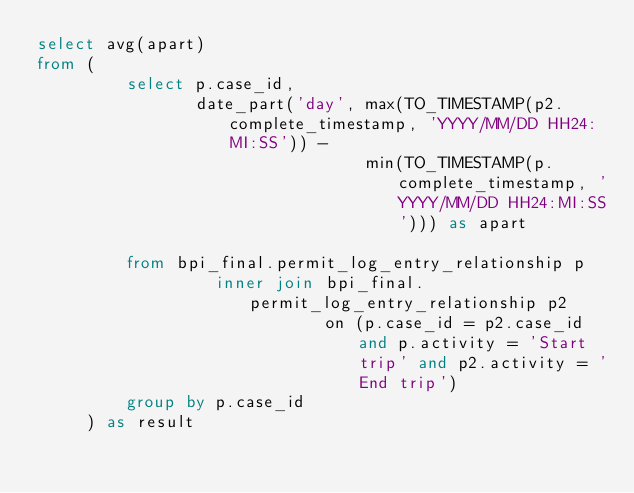<code> <loc_0><loc_0><loc_500><loc_500><_SQL_>select avg(apart)
from (
         select p.case_id,
                date_part('day', max(TO_TIMESTAMP(p2.complete_timestamp, 'YYYY/MM/DD HH24:MI:SS')) -
                                 min(TO_TIMESTAMP(p.complete_timestamp, 'YYYY/MM/DD HH24:MI:SS'))) as apart

         from bpi_final.permit_log_entry_relationship p
                  inner join bpi_final.permit_log_entry_relationship p2
                             on (p.case_id = p2.case_id and p.activity = 'Start trip' and p2.activity = 'End trip')
         group by p.case_id
     ) as result
</code> 